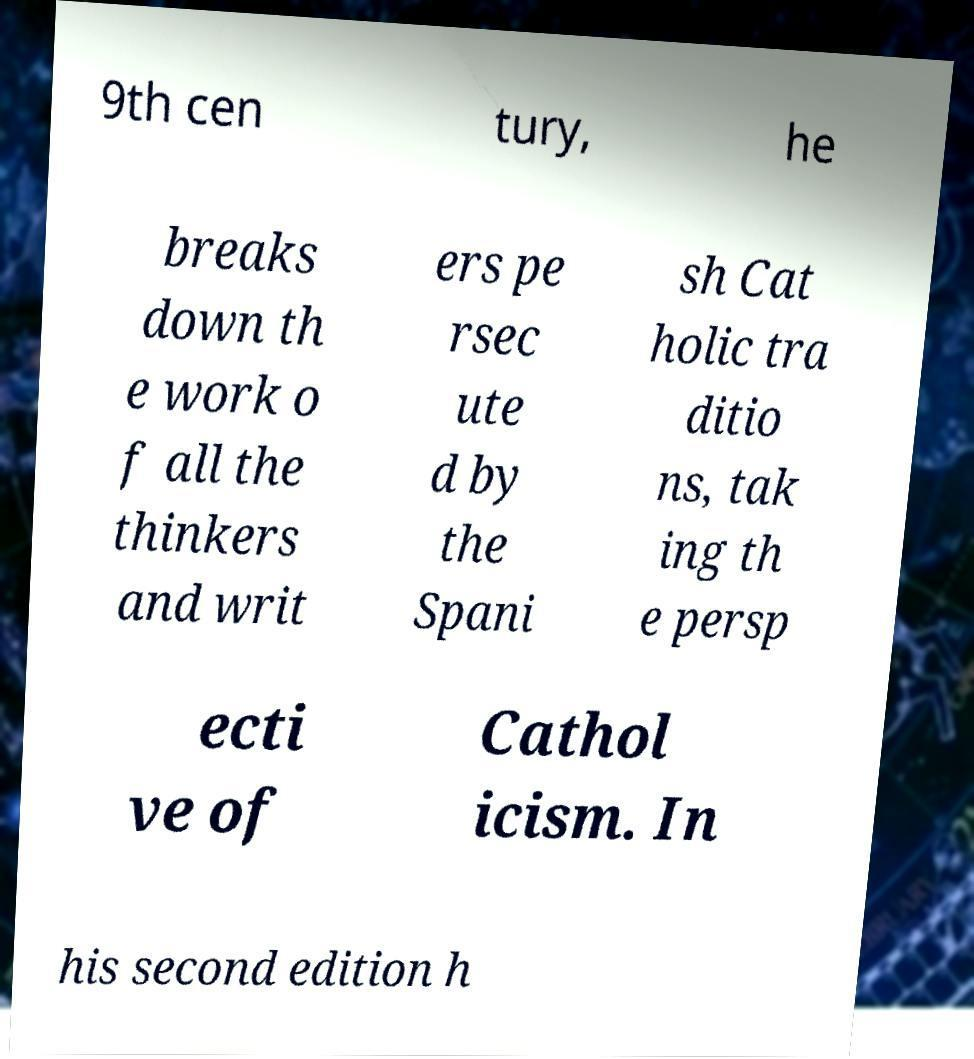There's text embedded in this image that I need extracted. Can you transcribe it verbatim? 9th cen tury, he breaks down th e work o f all the thinkers and writ ers pe rsec ute d by the Spani sh Cat holic tra ditio ns, tak ing th e persp ecti ve of Cathol icism. In his second edition h 